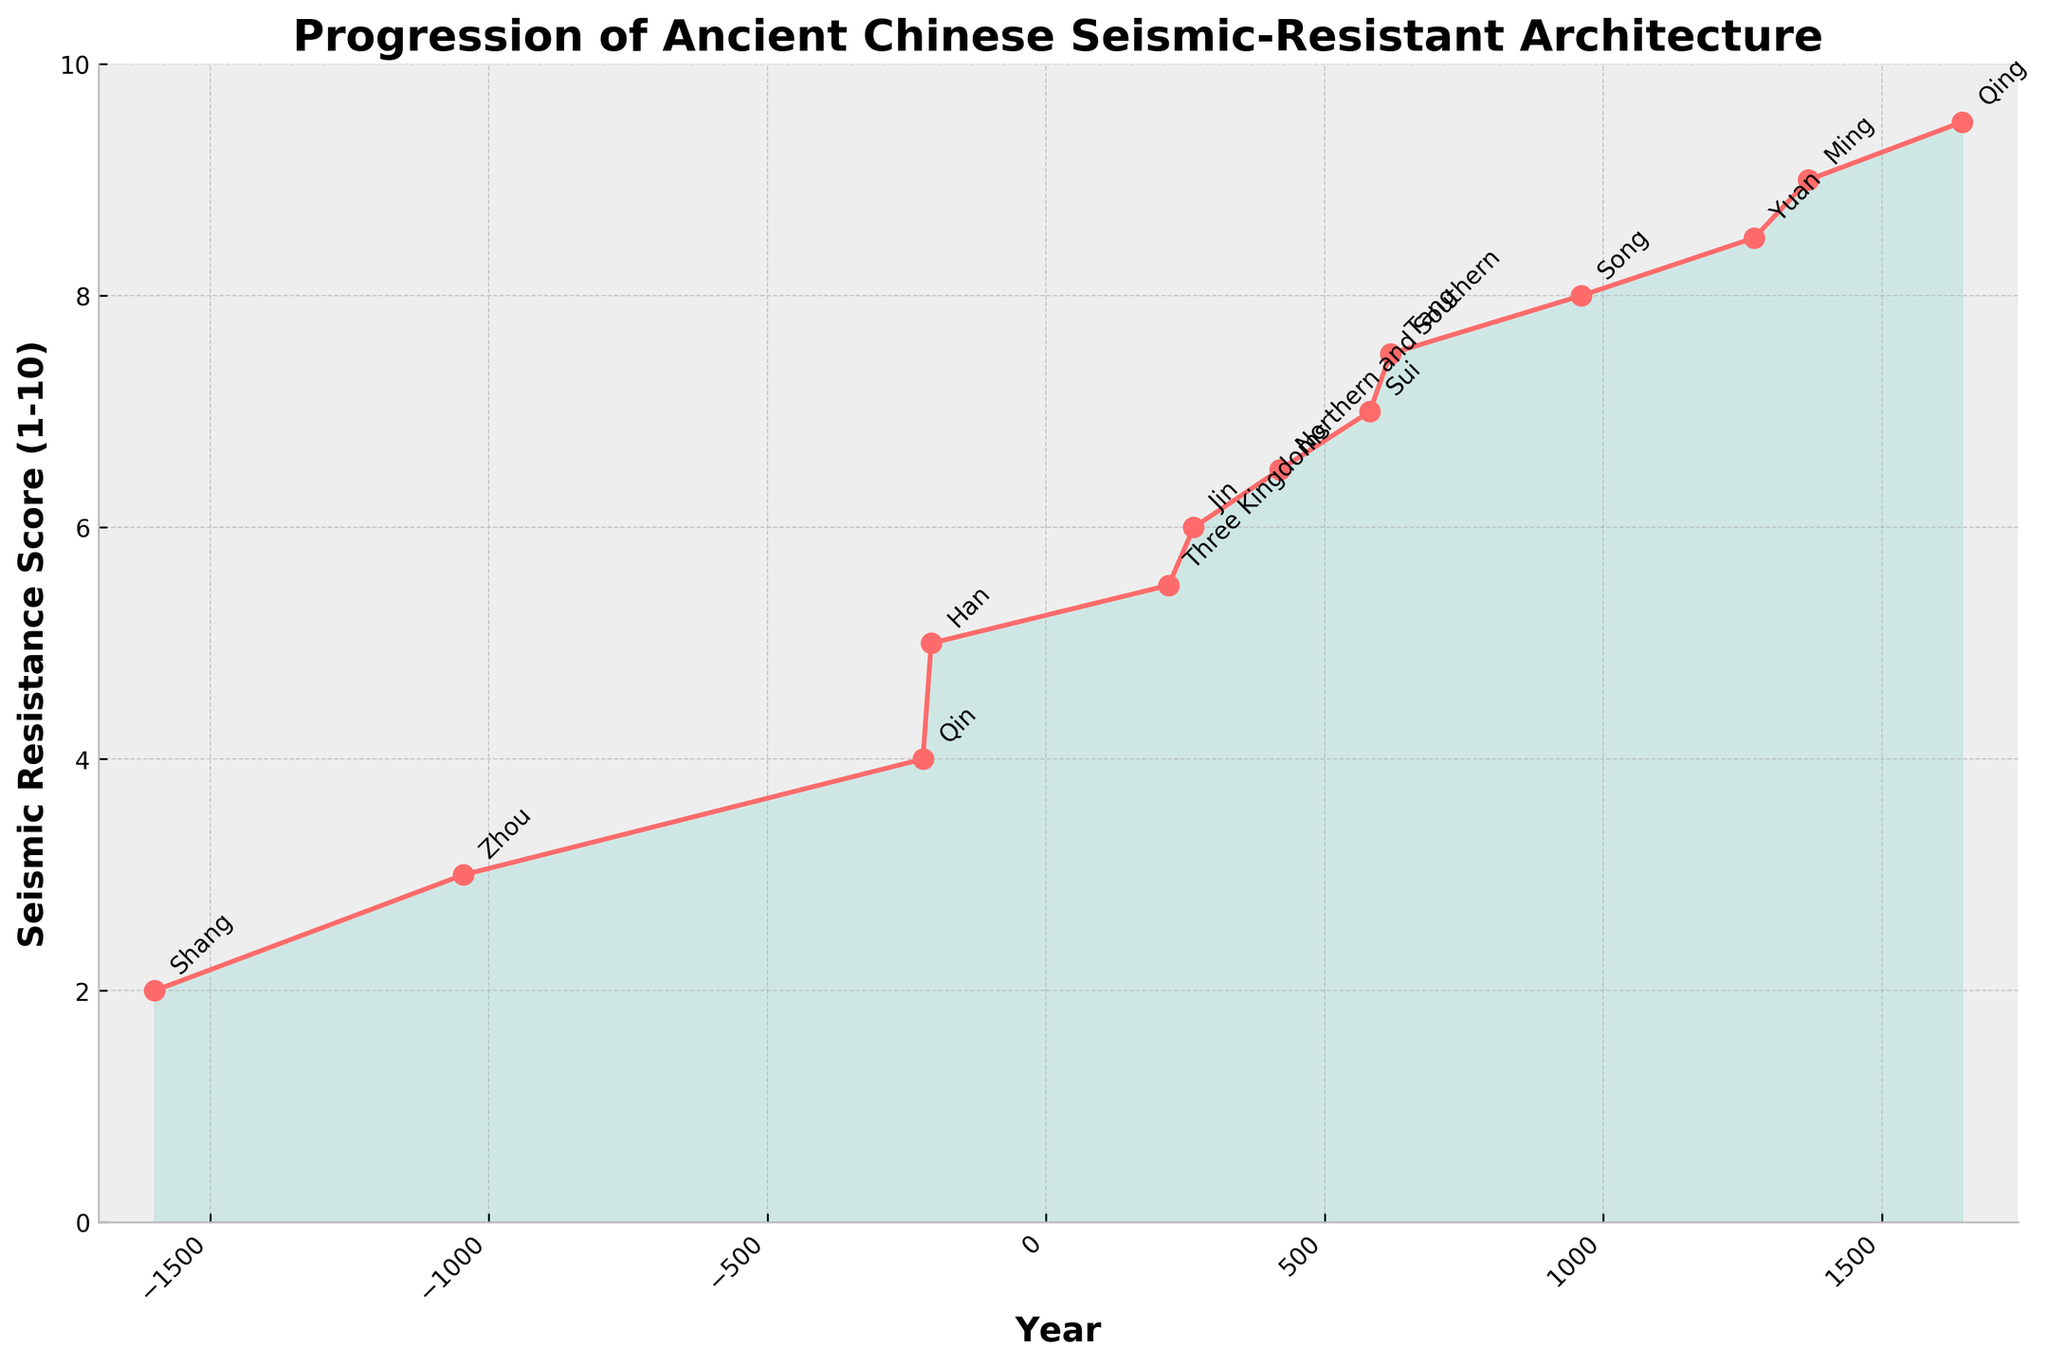What is the difference in the seismic resistance score between the Sui and Song dynasties? The seismic resistance score for the Sui dynasty is 7, and for the Song dynasty, it is 8. The difference is calculated as 8 - 7.
Answer: 1 How did the seismic resistance score change from the Tang to the Yuan dynasty? The score increased from 7.5 during the Tang dynasty to 8.5 during the Yuan dynasty. The difference is calculated as 8.5 - 7.5.
Answer: 1 Which dynasty shows the greatest improvement in seismic resistance compared to its immediate predecessor? By observing the line chart, the biggest increase is from the Qing dynasty (9.5) compared to the Ming dynasty (9). The increment is 0.5.
Answer: Qing Which dynasties have the same seismic resistance score, and what is that score? The Han and Three Kingdoms dynasties both have a seismic resistance score of 5.
Answer: Han and Three Kingdoms, 5 What can you infer about the general trend of seismic resistance scores from the Shang to the Qing dynasty? The scores generally show a steady increase over time, indicating continuous improvements in seismic-resistant architectural techniques.
Answer: Steady Increase What was the seismic resistance score of the Han dynasty, and how does it compare to the Zhou dynasty? The score for the Han dynasty is 5, and for the Zhou dynasty, it is 3. The Han score is higher by 5 - 3.
Answer: 5, 2 higher Between which two consecutive dynasties did the seismic resistance score first reach a value higher than 7? Comparing each consecutive pair, the score first exceeded 7 between the Sui (7) and Tang (7.5) dynasties.
Answer: Sui and Tang If the seismic resistance score improvement rate remained consistent from the Northern and Southern dynasty through the Tang dynasty, what would the estimated score be during Northern and Southern dynasty if it started from 5 during the Three Kingdoms dynasty? The score increased from 5 to 6.5 (+1.5) over two intervening periods (Three Kingdoms to Jin, Jin to Northern and Southern). If consistent, each period adds 1.5/2 = 0.75. Hence, after one period (Three Kingdoms to Jin), it would be 5 + 0.75 = 5.75, confirming Northern and Southern dynasty at 6.5 is consistent, indicating an increment trend.
Answer: 6.5 